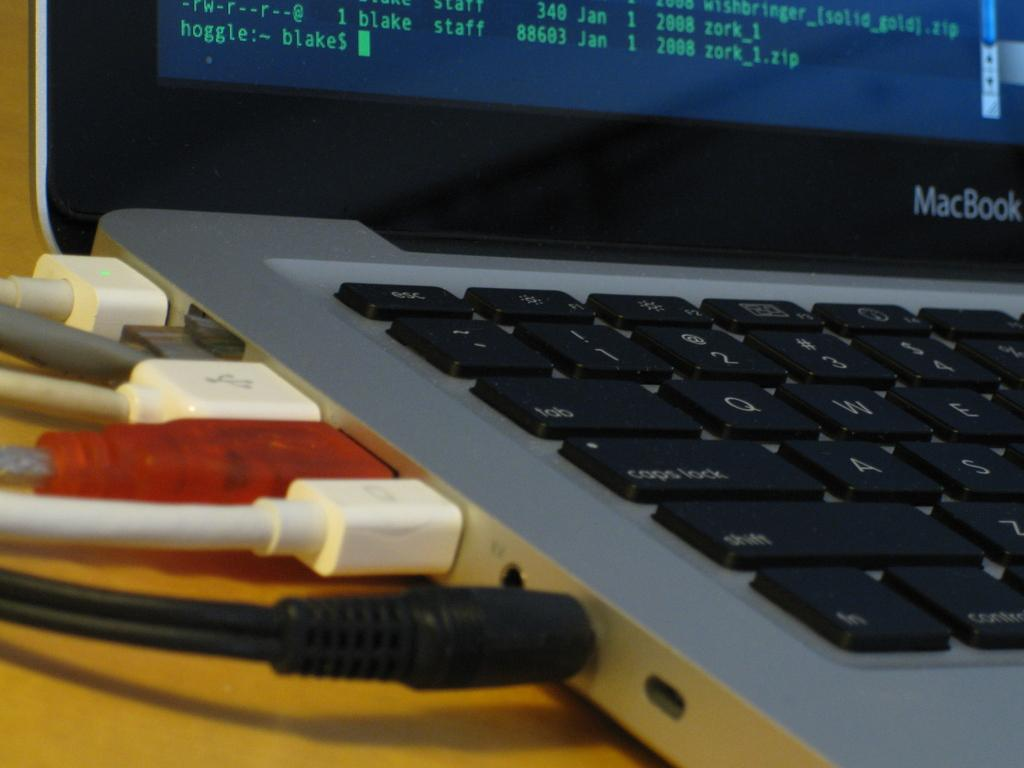<image>
Write a terse but informative summary of the picture. A clode up of several cables plugged into the side ports of a MacBook 